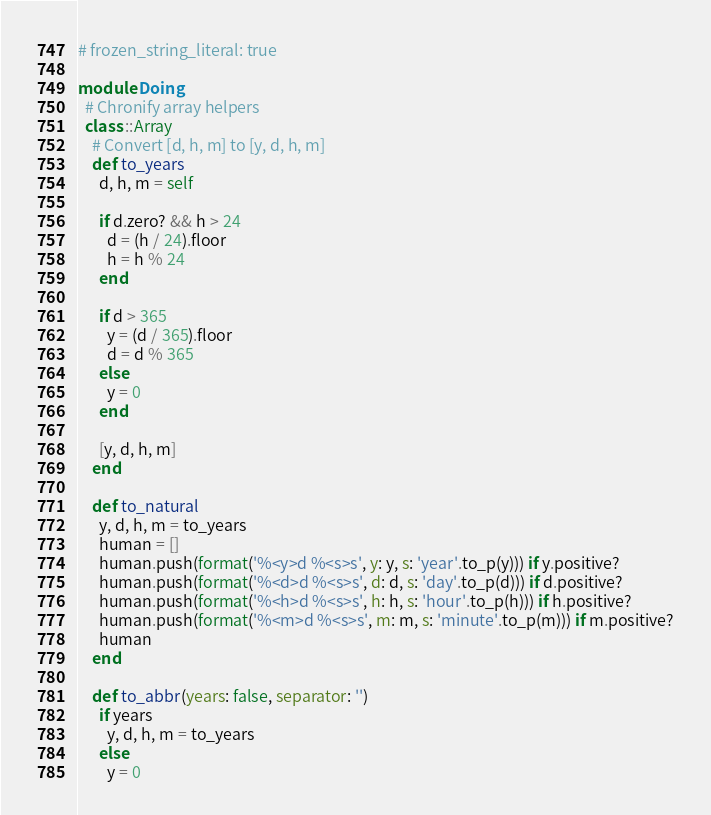<code> <loc_0><loc_0><loc_500><loc_500><_Ruby_># frozen_string_literal: true

module Doing
  # Chronify array helpers
  class ::Array
    # Convert [d, h, m] to [y, d, h, m]
    def to_years
      d, h, m = self

      if d.zero? && h > 24
        d = (h / 24).floor
        h = h % 24
      end

      if d > 365
        y = (d / 365).floor
        d = d % 365
      else
        y = 0
      end

      [y, d, h, m]
    end

    def to_natural
      y, d, h, m = to_years
      human = []
      human.push(format('%<y>d %<s>s', y: y, s: 'year'.to_p(y))) if y.positive?
      human.push(format('%<d>d %<s>s', d: d, s: 'day'.to_p(d))) if d.positive?
      human.push(format('%<h>d %<s>s', h: h, s: 'hour'.to_p(h))) if h.positive?
      human.push(format('%<m>d %<s>s', m: m, s: 'minute'.to_p(m))) if m.positive?
      human
    end

    def to_abbr(years: false, separator: '')
      if years
        y, d, h, m = to_years
      else
        y = 0</code> 